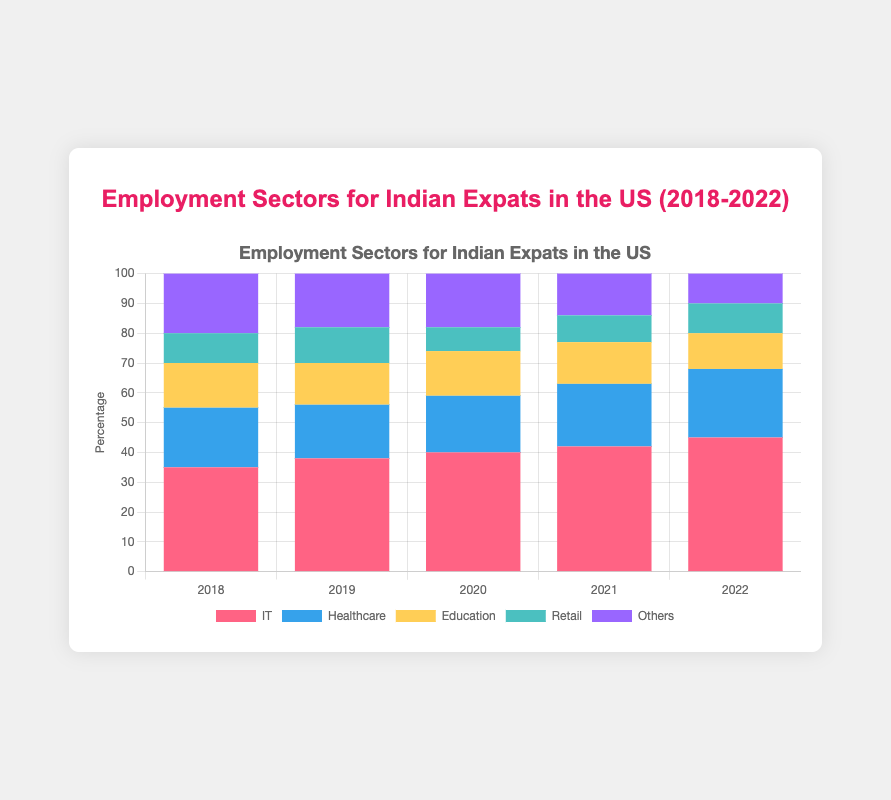What is the most popular employment sector for Indian expats in the US in 2022? According to the data and the corresponding stacked bar chart, IT is the most popular employment sector among Indian expats in 2022 as it has the highest percentage compared to other sectors.
Answer: IT What was the trend in the IT sector from 2018 to 2022? The percentage of Indian expats working in the IT sector increased every year from 35% in 2018 to 45% in 2022.
Answer: Increasing Which sector saw the most significant decrease from 2018 to 2022? The Retail sector saw the most significant decrease, dropping from 10% in 2018 to 8% in 2020 and then stabilizing around 9-10%. This shows a noticeable decline compared to other sectors.
Answer: Retail How does the Healthcare sector in 2022 compare to 2019? In 2019, 18% of Indian expats were employed in Healthcare. By 2022, this percentage increased to 23%.
Answer: Higher What is the combined percentage of Indian expats working in Healthcare and Education in 2020? Add the percentages of Healthcare (19%) and Education (15%) for the year 2020, resulting in a combined total of 34%.
Answer: 34% Which sector consistently had the same or increasing employment percentage every year? The IT sector had consistent increases in its employment percentage every year from 2018 to 2022.
Answer: IT What was the percentage change in the 'Others' category from 2018 to 2022? The percentage in the 'Others' category decreases from 20% in 2018 to 10% in 2022. This is a 50% reduction.
Answer: -50% Is the employment percentage in the Education sector higher or lower in 2022 compared to 2018? The percentage for Education in 2018 was 15%, and it decreased to 12% in 2022, indicating a lower percentage.
Answer: Lower Which color represents the Healthcare sector, and how did its percentage change from 2020 to 2021? The Healthcare sector is represented by blue. Its percentage increased from 19% in 2020 to 21% in 2021.
Answer: Blue; Increased What is the total percentage of Indian expats working in Retail and Others combined in 2021? The Retail sector was 9%, and the Others category was 14%. Combining these, the total percentage is 23%.
Answer: 23% 